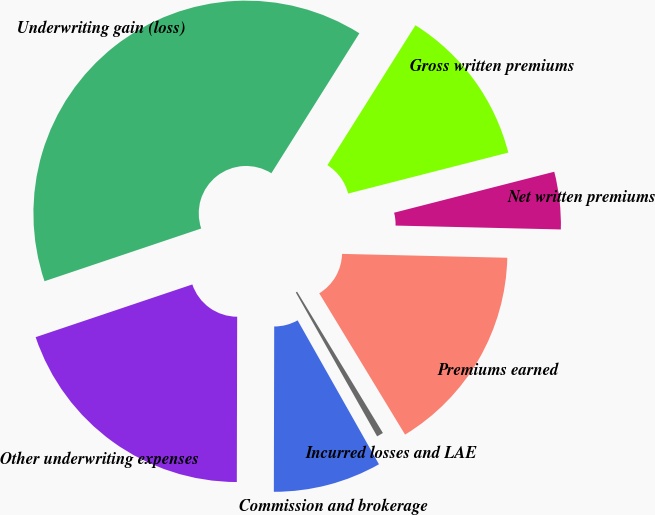Convert chart. <chart><loc_0><loc_0><loc_500><loc_500><pie_chart><fcel>Gross written premiums<fcel>Net written premiums<fcel>Premiums earned<fcel>Incurred losses and LAE<fcel>Commission and brokerage<fcel>Other underwriting expenses<fcel>Underwriting gain (loss)<nl><fcel>12.08%<fcel>4.36%<fcel>15.94%<fcel>0.5%<fcel>8.22%<fcel>19.8%<fcel>39.1%<nl></chart> 